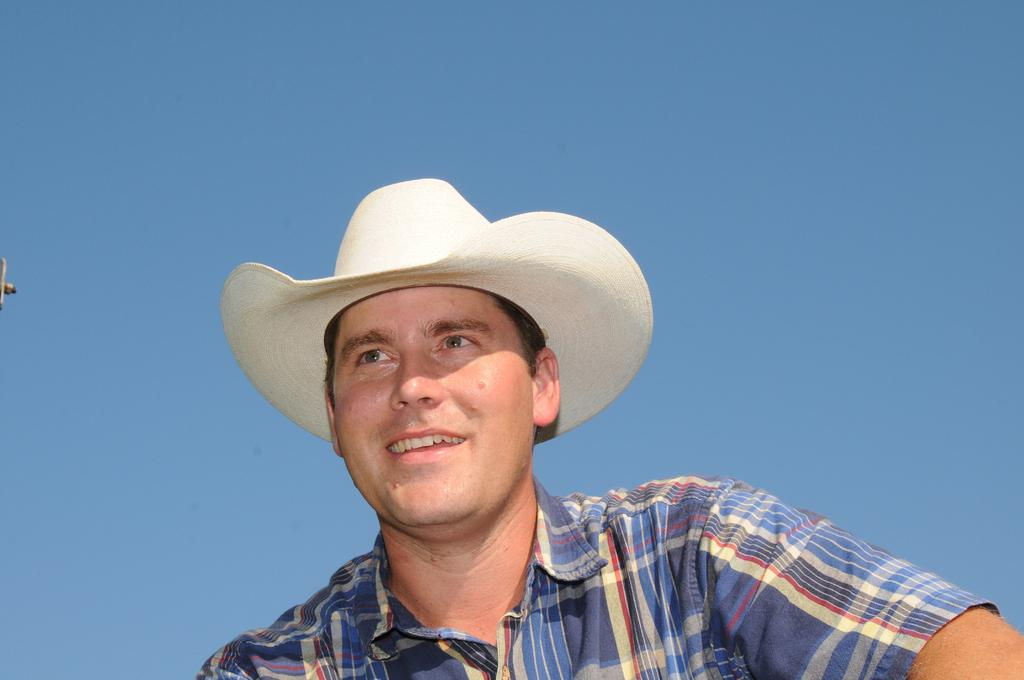Who is present in the image? There is a man in the image. What is the man doing in the image? The man is smiling in the image. What is the man wearing on his head? The man is wearing a hat in the image. What can be seen in the background of the image? The sky is visible in the background of the image. What is the color of the sky in the image? The color of the sky in the image is blue. What type of butter is being served by the man in the image? There is no butter or servant present in the image; it features a man wearing a hat and smiling. 